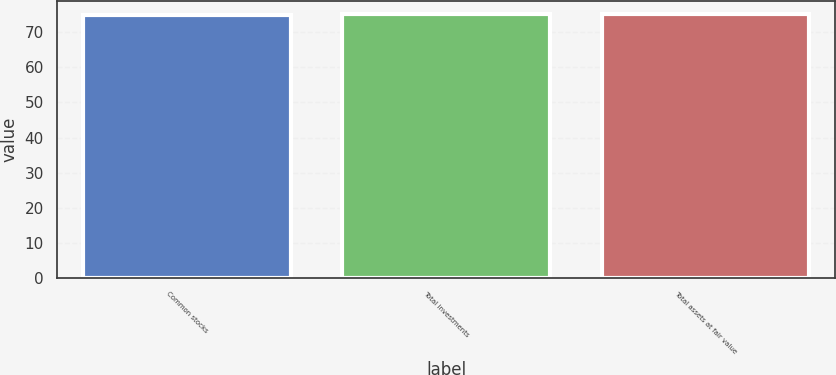Convert chart. <chart><loc_0><loc_0><loc_500><loc_500><bar_chart><fcel>Common stocks<fcel>Total investments<fcel>Total assets at fair value<nl><fcel>75<fcel>75.1<fcel>75.2<nl></chart> 